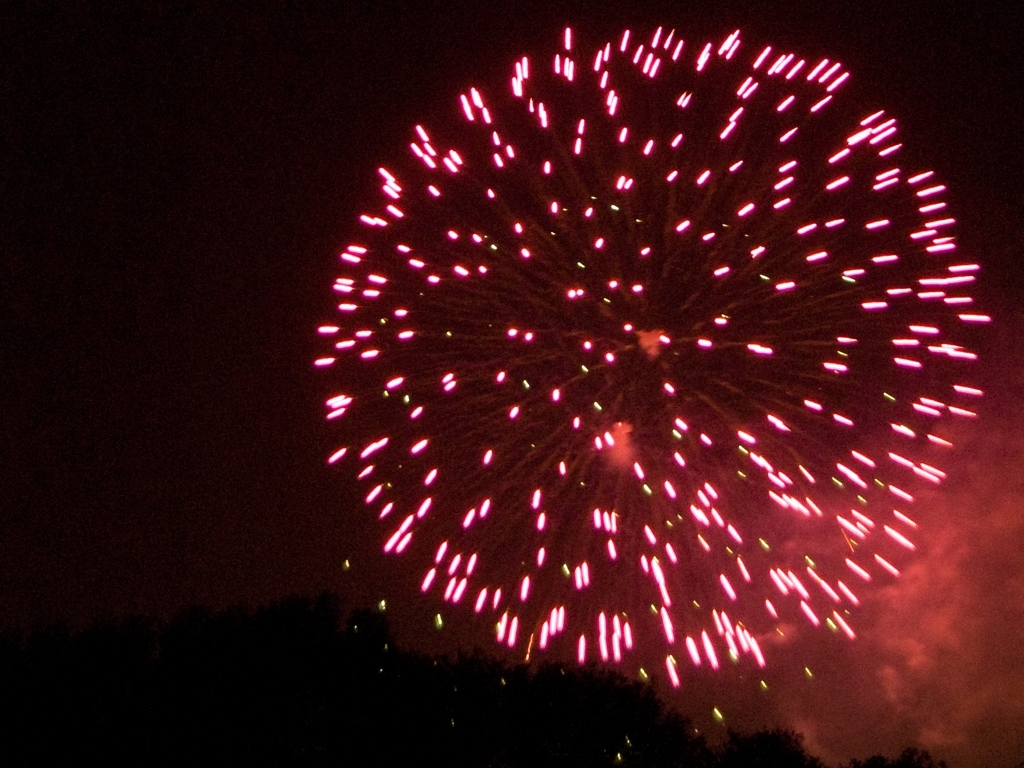Can you describe what's happening in this image and maybe when it might typically occur? This image captures a burst of fireworks, which are often used in celebrations or festive occasions like national holidays, New Year's Eve, or festivals. The vibrant pink trails are a result of the explosive pyrotechnics, as they illuminate the night sky. Such displays are choreographed to create visual spectacles in the air, and based on the darkness of the sky it seems to have been taken at night. Events with fireworks typically happen after sunset to maximize the visual effect of the colors against the dark backdrop. 